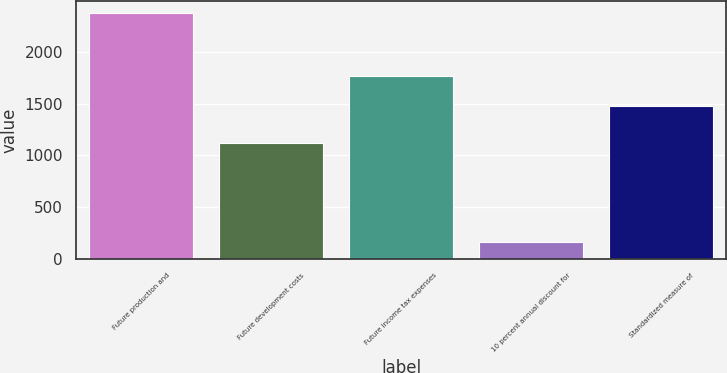<chart> <loc_0><loc_0><loc_500><loc_500><bar_chart><fcel>Future production and<fcel>Future development costs<fcel>Future income tax expenses<fcel>10 percent annual discount for<fcel>Standardized measure of<nl><fcel>2373<fcel>1119<fcel>1768<fcel>167<fcel>1474<nl></chart> 